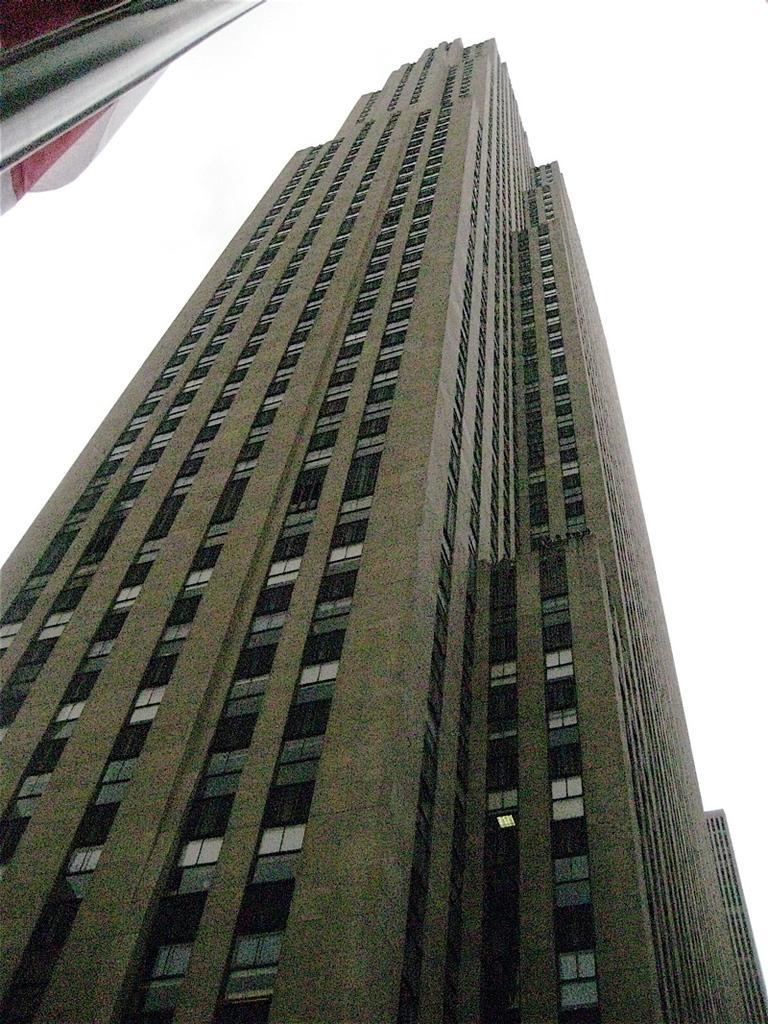What type of structures are present in the image? There are buildings in the image. What colors can be seen on the buildings? The buildings have black, white, and cream colors. Can you describe the object located in the left top of the image? Unfortunately, the facts provided do not give any information about the object in the left top of the image. What can be seen in the background of the image? The sky is visible in the background of the image. How much money is being exchanged between the buildings in the image? There is no indication of money being exchanged between the buildings in the image. What type of amusement can be seen in the image? There is no amusement present in the image; it features buildings with black, white, and cream colors, and an object in the left top of the image. 